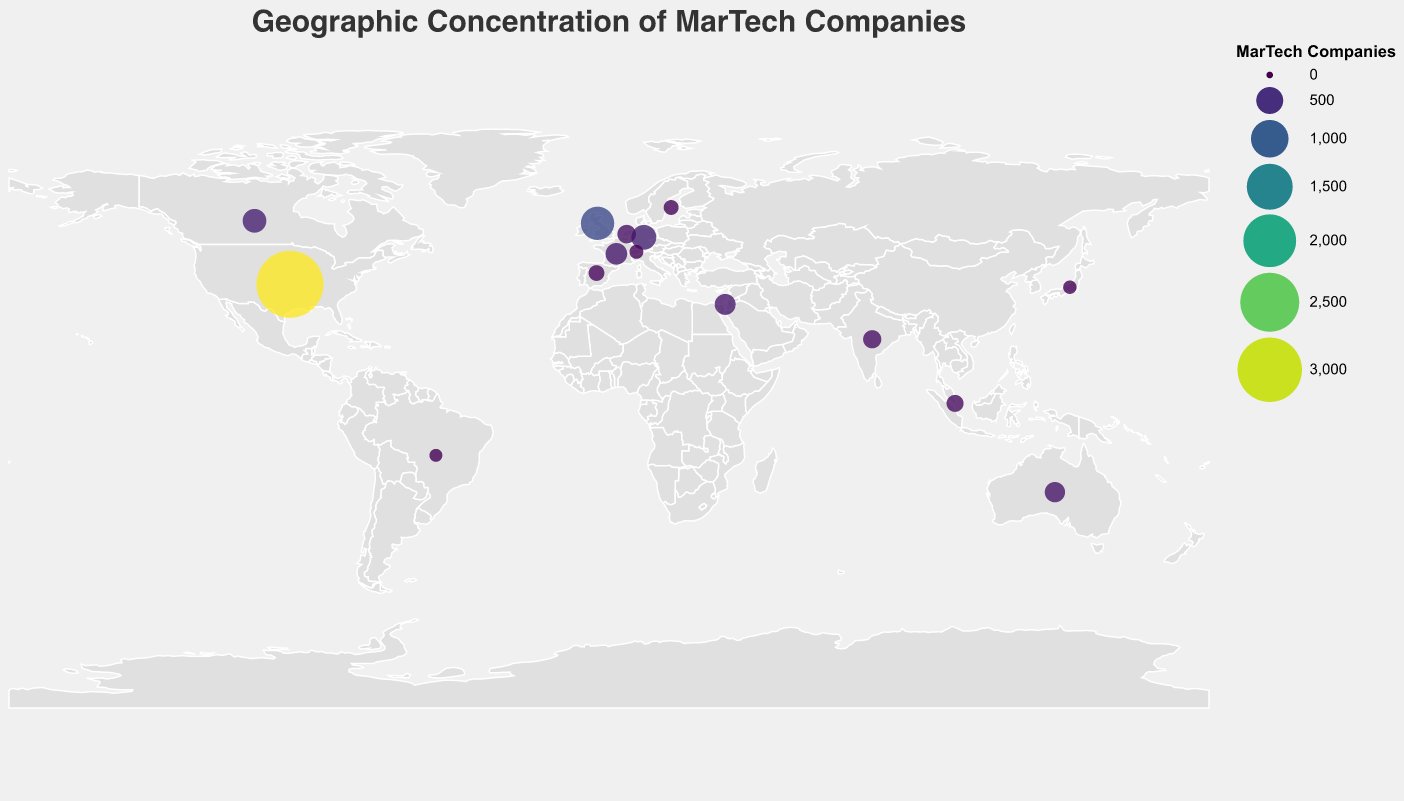What is the title of the plot? The title is prominently displayed at the top of the plot in a larger font size. It reads "Geographic Concentration of MarTech Companies".
Answer: Geographic Concentration of MarTech Companies Which country has the highest number of MarTech companies? The largest circle on the plot represents the country with the highest number of MarTech companies. By referring to the tooltip and the size of the circle, it's clear that the United States has the highest number, with 3250 companies.
Answer: United States How many countries have more than 300 MarTech companies? By examining the circles and their corresponding tooltips on the plot, we can see that the countries with more than 300 MarTech companies are: United States, United Kingdom, Germany, Canada, and France. This totals to 5 countries.
Answer: 5 Which country has more MarTech companies, Germany or Canada? By comparing the circles and tooltips for Germany and Canada, we see that Germany has 420 MarTech companies, while Canada has 380. Therefore, Germany has more MarTech companies.
Answer: Germany What is the total number of MarTech companies in the top three countries combined? The top three countries by the number of MarTech companies are the United States, United Kingdom, and Germany. Summing their values: 3250 (US) + 780 (UK) + 420 (Germany) = 4450 companies.
Answer: 4450 Which countries have fewer than 200 MarTech companies? By looking at the tooltips for each country, the countries with fewer than 200 MarTech companies are: Singapore (180), Spain (150), Sweden (130), Switzerland (110), Japan (100), and Brazil (90). This totals to 6 countries.
Answer: 6 What is the average number of MarTech companies across all countries shown in the plot? Summing up the MarTech companies for all listed countries: 3250 + 780 + 420 + 380 + 310 + 290 + 270 + 220 + 210 + 180 + 150 + 130 + 110 + 100 + 90 = 6890. Dividing by the number of countries, which is 15, we get: 6890 / 15 ≈ 459.33.
Answer: 459.33 How does the distribution of MarTech companies visually differ between the United States and Brazil? The United States has the largest circle indicating a very high concentration of MarTech companies (3250), while Brazil has one of the smallest circles, showing a low concentration (90). The dramatic size difference visually represents the concentration disparity.
Answer: The United States has a much larger circle than Brazil, indicating a significantly higher concentration of MarTech companies 